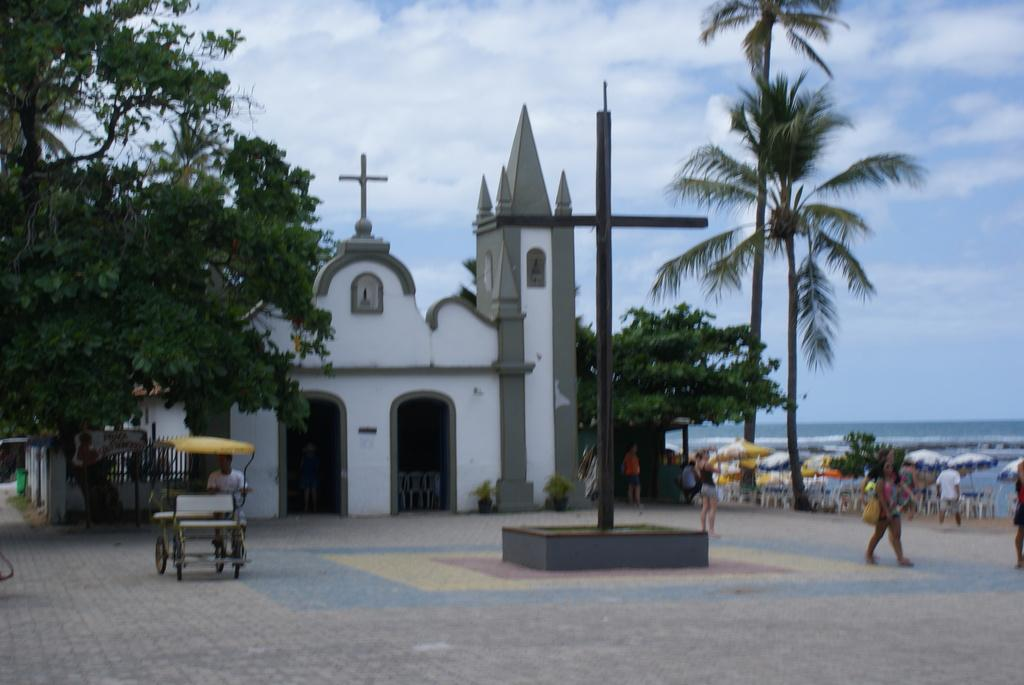What is the main structure in the middle of the image? There is a church in the middle of the image. What type of vegetation is on the right side of the image? There are trees on the right side of the image. What is the man on the left side of the image doing? A man is riding a vehicle on the left side of the image. What is the weather like in the image? The sky is sunny and visible at the top of the image. Where can the man find a berry to eat in the image? There are no berries present in the image, so the man cannot find any to eat. What type of hook is attached to the church in the image? There is no hook attached to the church in the image. 